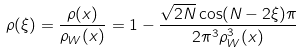<formula> <loc_0><loc_0><loc_500><loc_500>\rho ( \xi ) = \frac { \rho ( x ) } { \rho _ { W } ( x ) } = 1 - \frac { \sqrt { 2 N } \cos ( N - 2 \xi ) \pi } { 2 \pi ^ { 3 } \rho ^ { 3 } _ { W } ( x ) }</formula> 